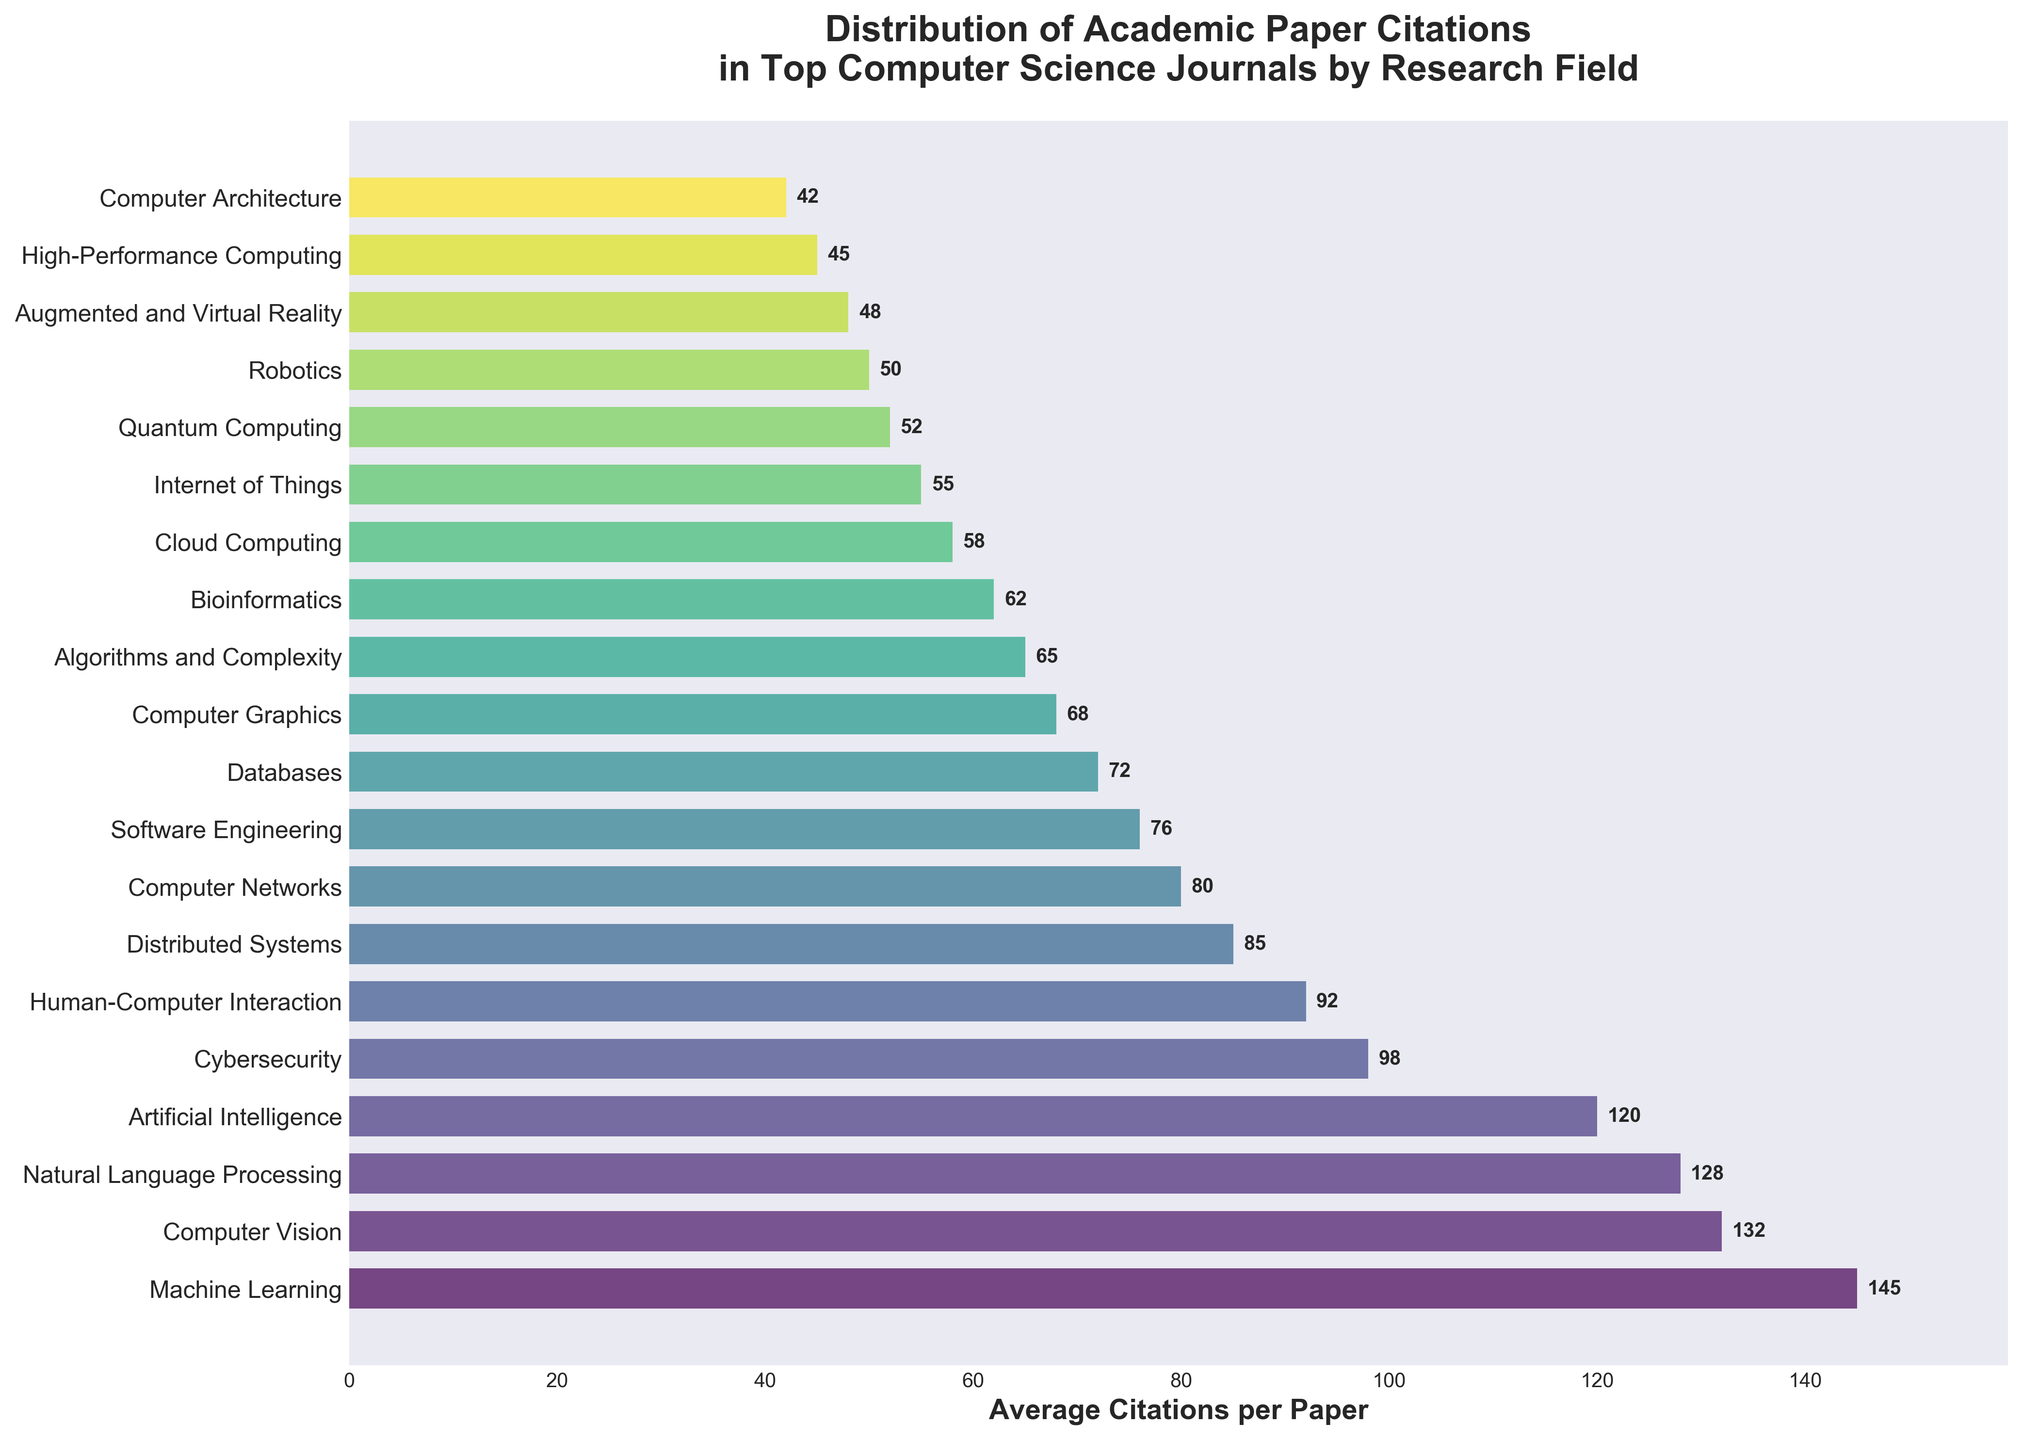Which research field has the highest average citations per paper? By looking at the figure, locate the bar with the greatest length to identify the research field with the highest average citations. The longest bar represents 'Machine Learning' with 145 citations.
Answer: Machine Learning What is the difference in average citations per paper between Computer Vision and Cybersecurity? Find the bars corresponding to 'Computer Vision' and 'Cybersecurity' and note their values (132 and 98, respectively). Subtract the smaller value from the larger one: 132 - 98 = 34.
Answer: 34 Which research field has fewer average citations per paper, Bioinformatics or Quantum Computing? Compare the lengths of the bars for 'Bioinformatics' and 'Quantum Computing'. Bioinformatics has 62 average citations, and Quantum Computing has 52. Since 52 < 62, Quantum Computing has fewer citations.
Answer: Quantum Computing How many research fields have an average of more than 100 citations per paper? Count the number of bars with values exceeding 100. The fields are 'Machine Learning', 'Computer Vision', 'Natural Language Processing', and 'Artificial Intelligence'. There are 4 such fields.
Answer: 4 What is the average number of citations for Computer Networks, Software Engineering, and Databases? Add the citations for these fields (80, 76, and 72) and divide by the number of fields. (80 + 76 + 72) / 3 = 228 / 3 = 76.
Answer: 76 In terms of visual length, which research field's bar is closest to that of Human-Computer Interaction? Compare the length of the bar for 'Human-Computer Interaction' (92) with adjacent bars to find the closest value. 'Cybersecurity' has 98 citations and is closest in length.
Answer: Cybersecurity What is the combined total of average citations per paper for Distributed Systems and High-Performance Computing? Add the average citations for 'Distributed Systems' (85) and 'High-Performance Computing' (45). 85 + 45 = 130.
Answer: 130 Which research field has a shorter average citation count, Robotics or Computer Graphics? Compare the bars for 'Robotics' (50) and 'Computer Graphics' (68). Since 50 < 68, Robotics has a shorter average citation count.
Answer: Robotics What are the average citations per paper for the middle research field in the list? Identify the middle research field by counting the total fields and dividing by 2. With 19 fields, the middle one is the 10th, which is 'Databases' with 72 citations.
Answer: 72 